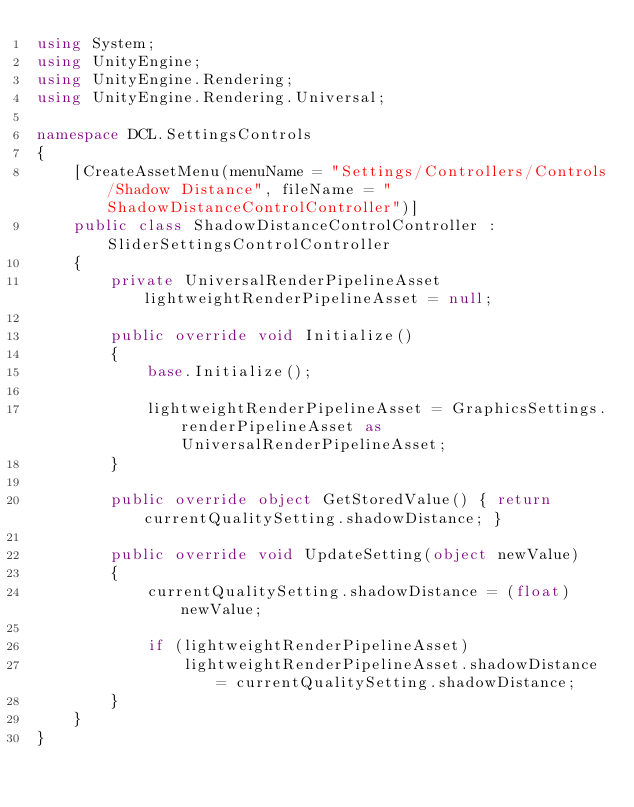<code> <loc_0><loc_0><loc_500><loc_500><_C#_>using System;
using UnityEngine;
using UnityEngine.Rendering;
using UnityEngine.Rendering.Universal;

namespace DCL.SettingsControls
{
    [CreateAssetMenu(menuName = "Settings/Controllers/Controls/Shadow Distance", fileName = "ShadowDistanceControlController")]
    public class ShadowDistanceControlController : SliderSettingsControlController
    {
        private UniversalRenderPipelineAsset lightweightRenderPipelineAsset = null;

        public override void Initialize()
        {
            base.Initialize();

            lightweightRenderPipelineAsset = GraphicsSettings.renderPipelineAsset as UniversalRenderPipelineAsset;
        }

        public override object GetStoredValue() { return currentQualitySetting.shadowDistance; }

        public override void UpdateSetting(object newValue)
        {
            currentQualitySetting.shadowDistance = (float)newValue;

            if (lightweightRenderPipelineAsset)
                lightweightRenderPipelineAsset.shadowDistance = currentQualitySetting.shadowDistance;
        }
    }
}</code> 